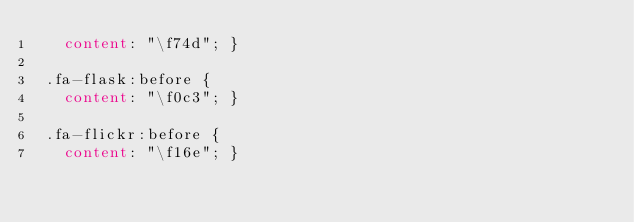Convert code to text. <code><loc_0><loc_0><loc_500><loc_500><_CSS_>   content: "\f74d"; }
 
 .fa-flask:before {
   content: "\f0c3"; }
 
 .fa-flickr:before {
   content: "\f16e"; }
 </code> 